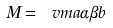Convert formula to latex. <formula><loc_0><loc_0><loc_500><loc_500>M = \ v m { a } { \alpha } { \beta } { b }</formula> 